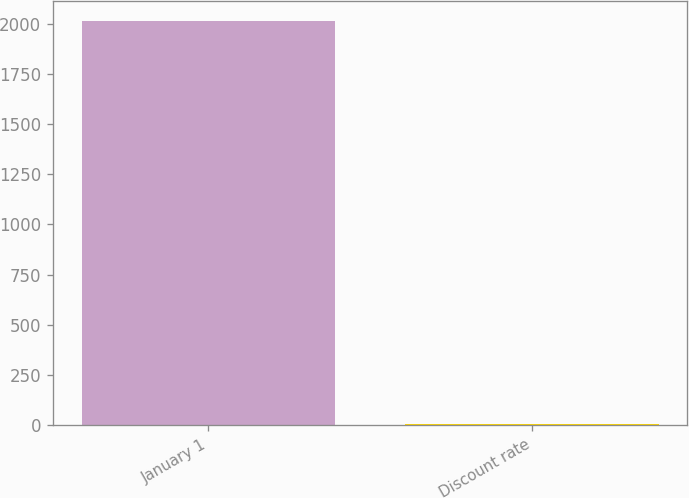<chart> <loc_0><loc_0><loc_500><loc_500><bar_chart><fcel>January 1<fcel>Discount rate<nl><fcel>2012<fcel>5.1<nl></chart> 